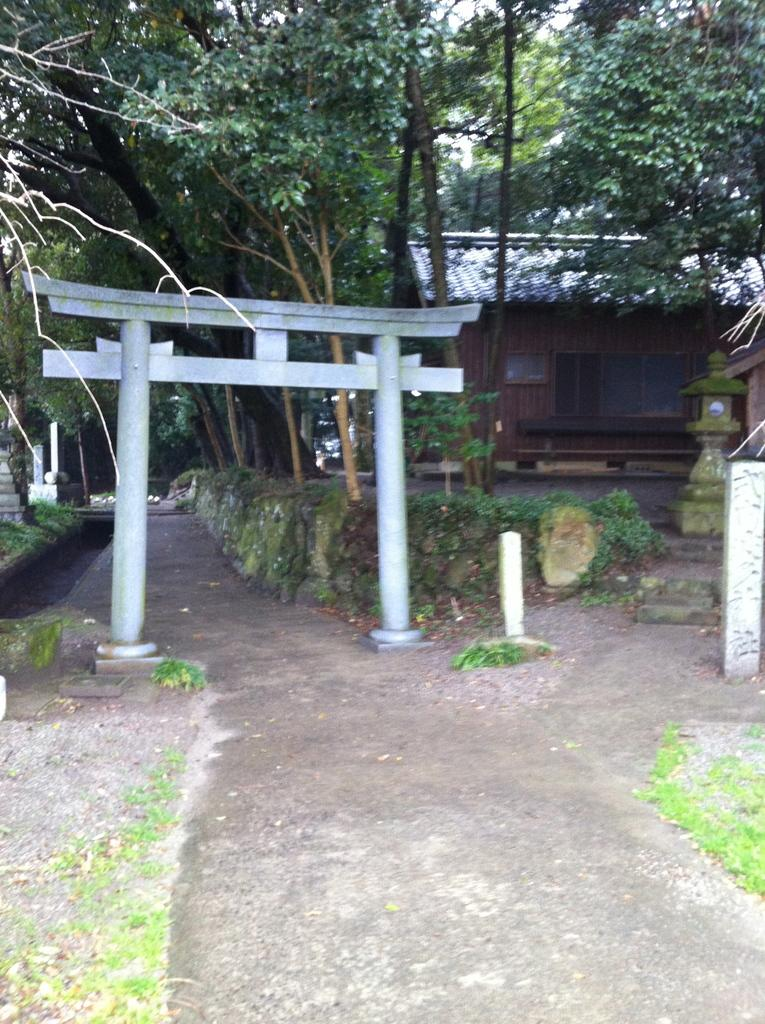What is the main structure in the center of the image? There is an arch in the center of the image. What is visible in front of the image? There is a road in front of the image. What can be seen in the background of the image? There is a house and trees in the background of the image. What type of vessel is floating in the background of the image? There is no vessel present in the image; it only features an arch, a road, a house, and trees. 